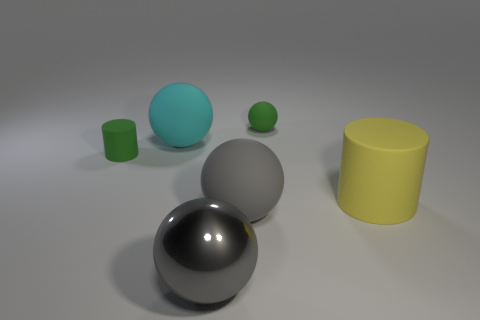Can you describe the composition and colors of the objects in the image? Certainly! The image displays a collection of geometric objects arranged on a flat surface. From left to right, we have a small green matte cylinder, a slightly larger teal matte sphere, a small green matte sphere, and a large shiny black sphere. Behind these, there's a large grey matte sphere and further back, a large yellow matte cylinder. The objects provide a contrast of colors, with varying shades of green, teal, grey, yellow, and black, as well as a mix of textures from matte to shiny finishes. 